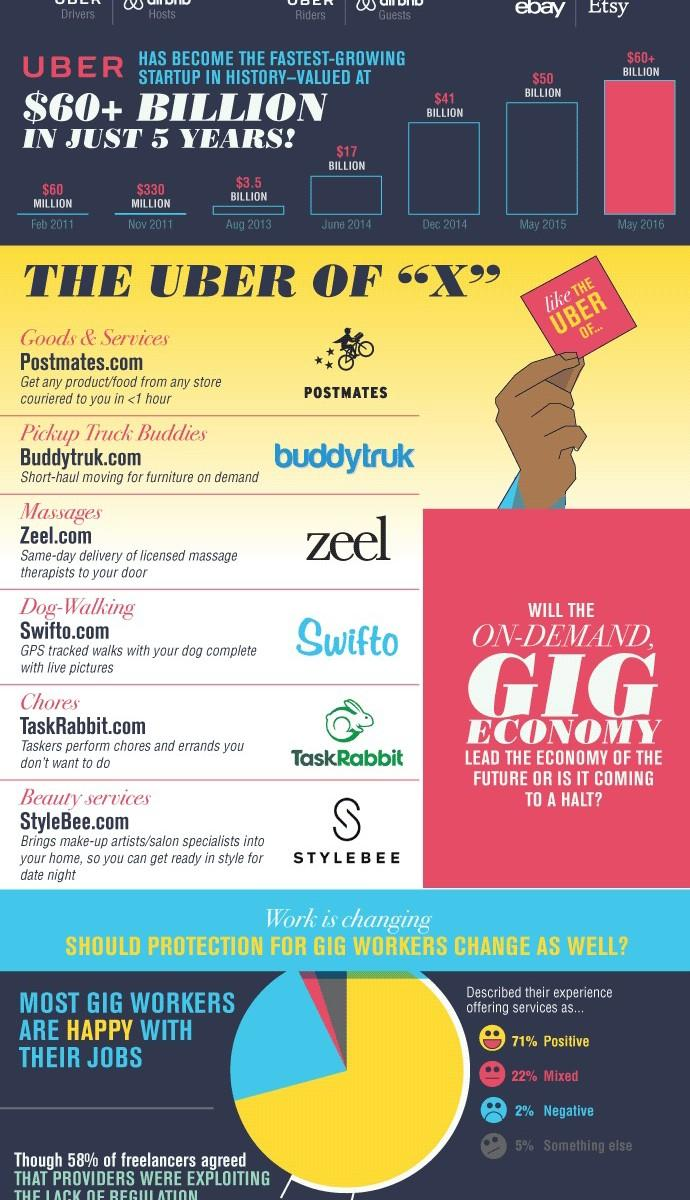Specify some key components in this picture. During the period of February 2011 to November 2011, the value of Uber grew from 270 million to a significant milestone. Nine out of 10 gig workers reported having a positive or mixed experience, according to a recent survey. The red note held by the hand contains text that reads 'THE UBER OF...' 